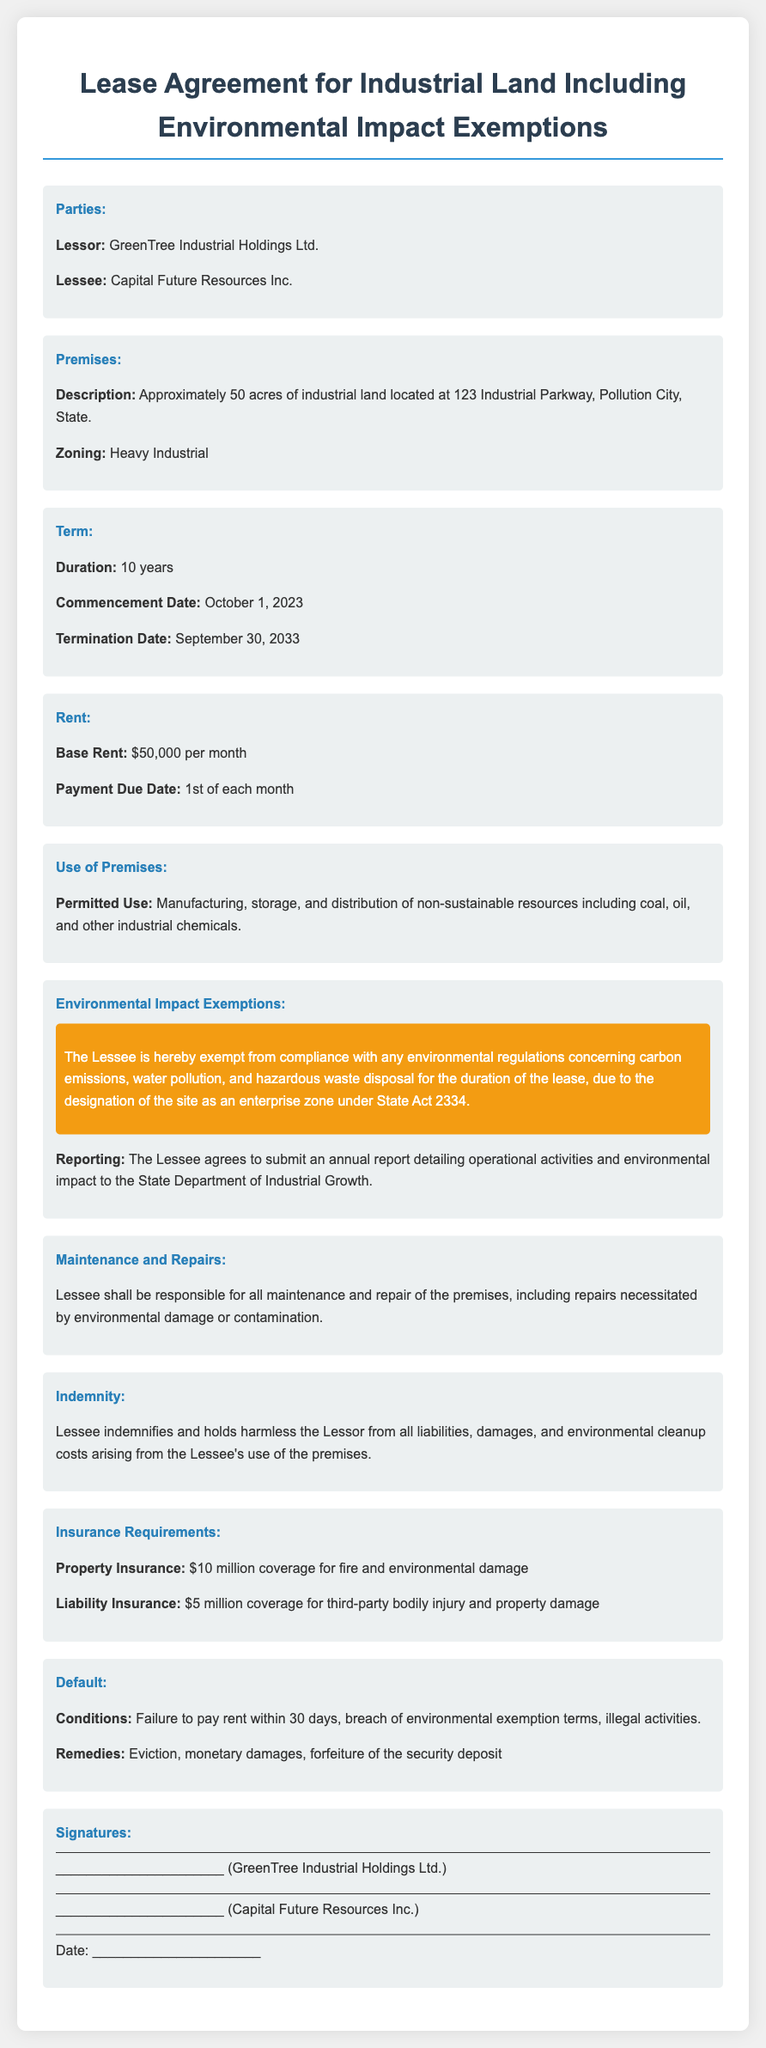what is the name of the Lessor? The Lessor is identified as GreenTree Industrial Holdings Ltd.
Answer: GreenTree Industrial Holdings Ltd who is the Lessee? The document states that the Lessee is Capital Future Resources Inc.
Answer: Capital Future Resources Inc how many acres of land is leased? The Premises section specifies that the lease includes approximately 50 acres of land.
Answer: 50 acres what is the base rent per month? The rent section indicates that the base rent is $50,000 per month.
Answer: $50,000 what is the duration of the lease? The term section specifies that the lease duration is for 10 years.
Answer: 10 years when does the lease commence? The commencement date is listed as October 1, 2023.
Answer: October 1, 2023 what are the permitted uses of the premises? The document states that the permitted use includes manufacturing, storage, and distribution of non-sustainable resources.
Answer: Manufacturing, storage, and distribution of non-sustainable resources what is the indemnity requirement for the Lessee? The Lessee must indemnify and hold harmless the Lessor from liabilities arising from the Lessee's use of the premises.
Answer: Indemnify and hold harmless what is the insurance coverage requirement for environmental damage? The insurance section specifies a property insurance coverage of $10 million for environmental damage.
Answer: $10 million what happens if the Lessee fails to pay rent within 30 days? The default section states that failure to pay rent within 30 days can lead to eviction.
Answer: Eviction 